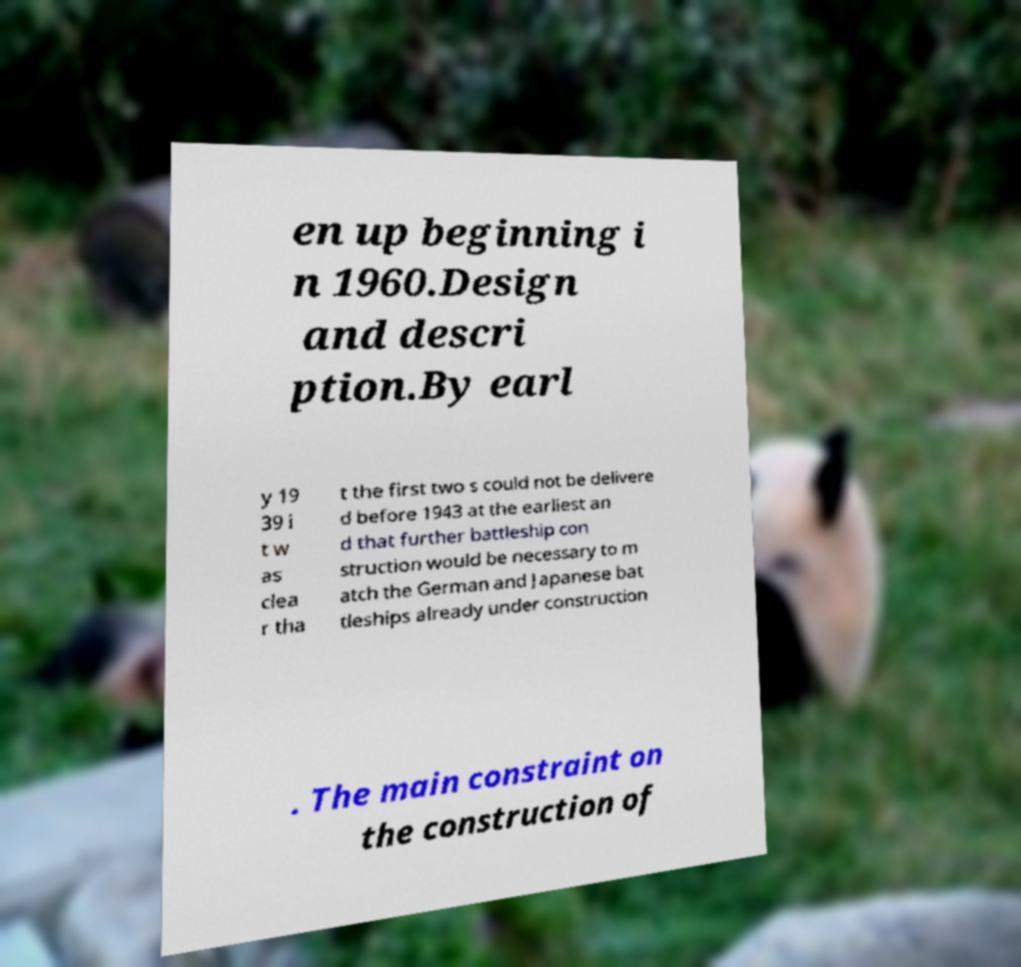For documentation purposes, I need the text within this image transcribed. Could you provide that? en up beginning i n 1960.Design and descri ption.By earl y 19 39 i t w as clea r tha t the first two s could not be delivere d before 1943 at the earliest an d that further battleship con struction would be necessary to m atch the German and Japanese bat tleships already under construction . The main constraint on the construction of 